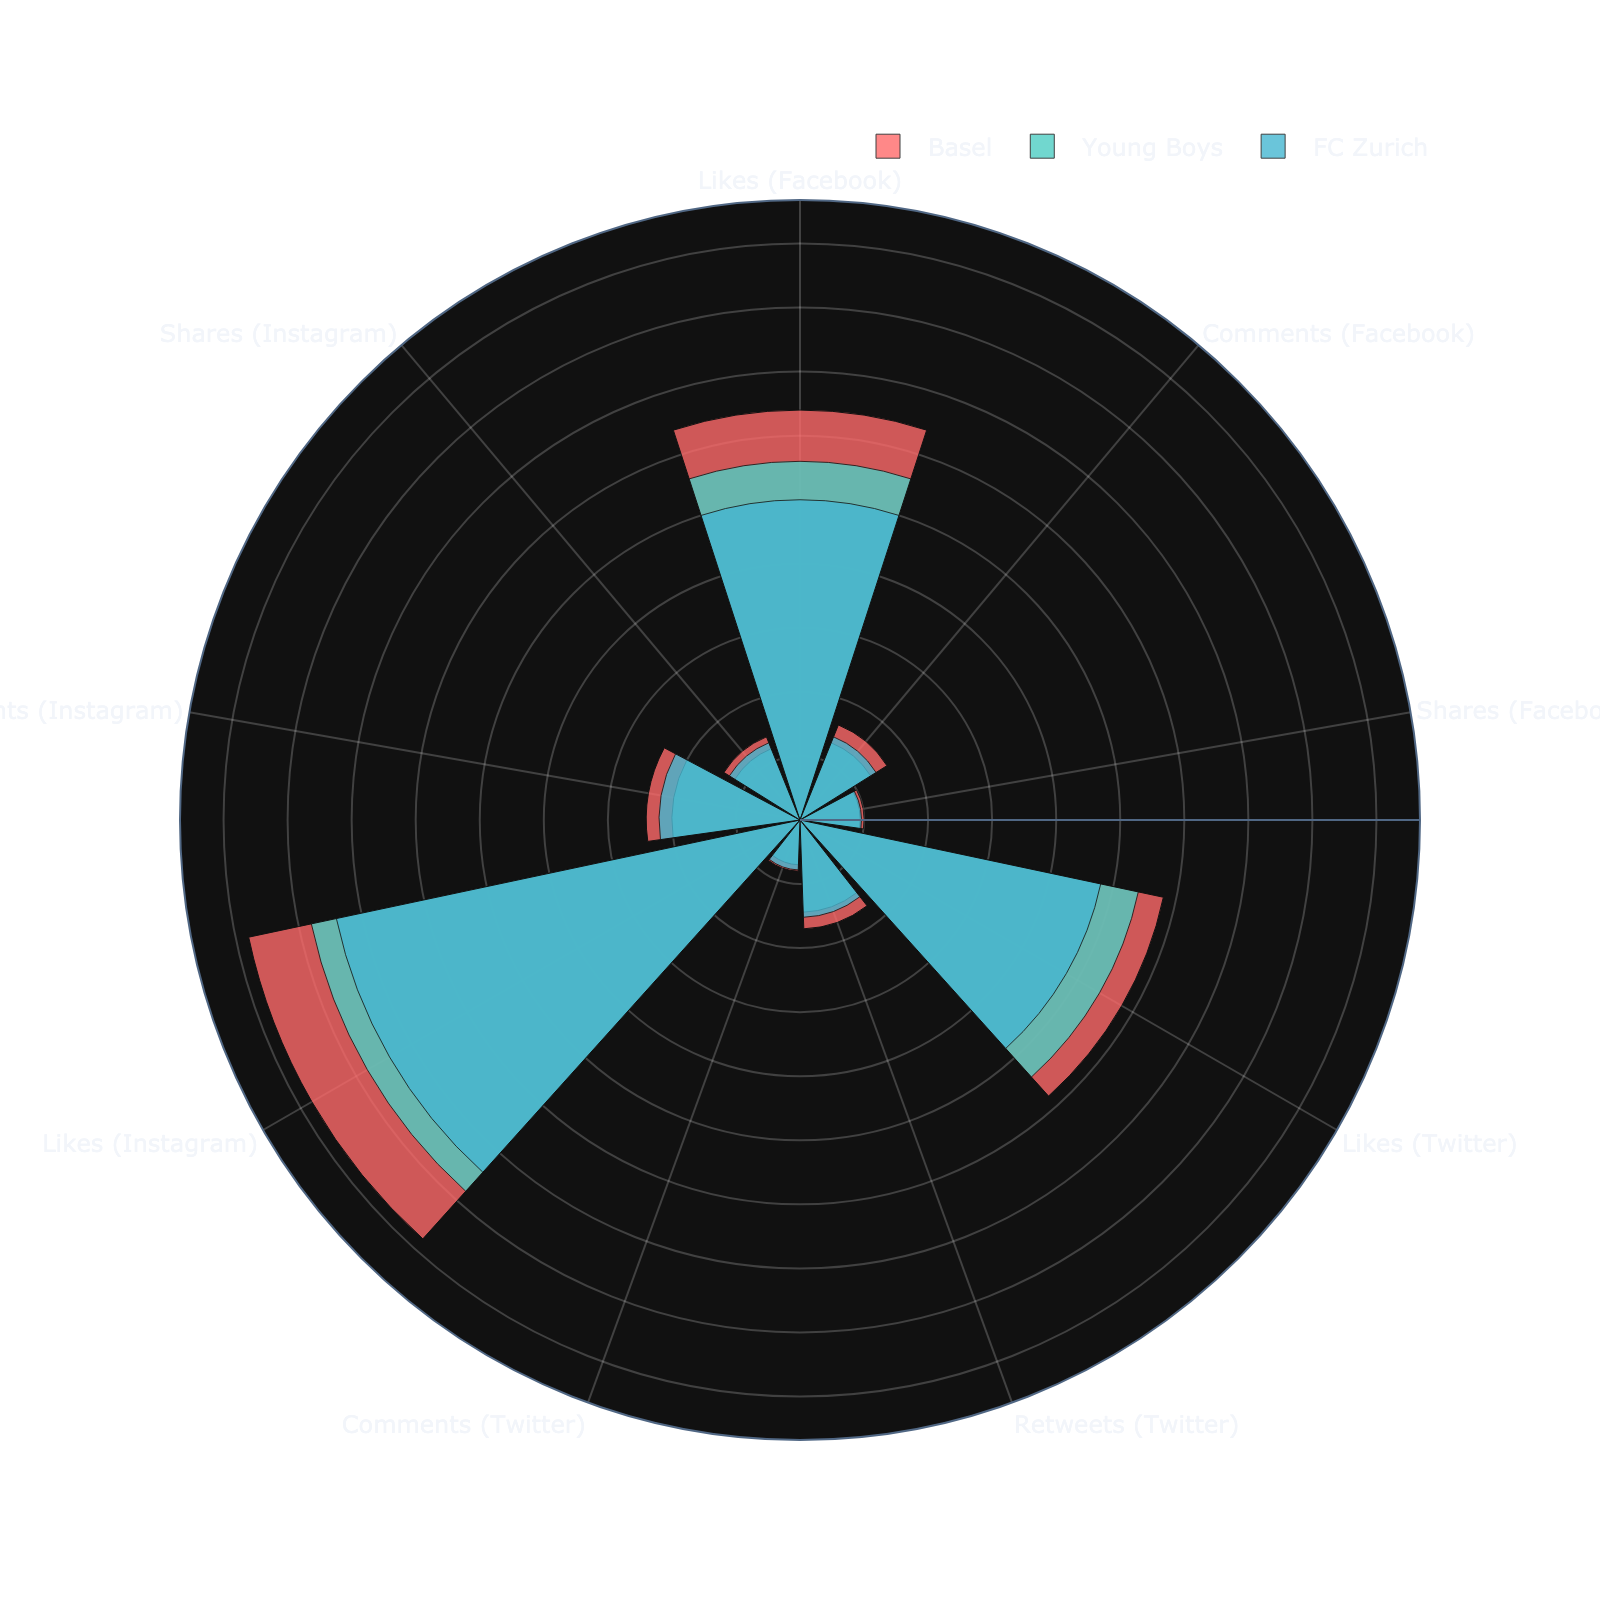What is the total number of Likes for Basel on Instagram? Add the Likes for Basel on Instagram, which is 44000.
Answer: 44000 Which platform has the highest engagement metric for FC Zurich? By looking at the data for FC Zurich, Instagram has the highest number of Likes (37000), Comments (11000), and Shares (6500), all higher than the same metrics on Facebook and Twitter.
Answer: Instagram How many more Comments does Basel have on Instagram compared to Twitter? Basel's Comments on Instagram are 12000, and on Twitter are 4000. The difference is 12000 - 4000 = 8000.
Answer: 8000 Among the three teams, which one has the highest number of Shares on Facebook? For each team on Facebook: Basel (5000), Young Boys (4700), FC Zurich (4800). Basel has the highest number.
Answer: Basel What is the average number of Likes across all platforms for Young Boys? Add Likes for Young Boys across all platforms: 28000 (Facebook) + 27000 (Twitter) + 39000 (Instagram) = 94000. Then, divide by 3 platforms: 94000 / 3 ≈ 31333.
Answer: 31333 Does FC Zurich have more Retweets on Twitter or more Comments on Facebook? FC Zurich has 7600 Retweets on Twitter and 7000 Comments on Facebook. 7600 is greater than 7000.
Answer: Retweets on Twitter Which engagement metric is the lowest for Basel on any platform? Checking Basel’s values: Likes (32000, 29000, 44000), Comments (8000, 4000, 12000), Shares (5000, 8500, 7000), the lowest is Comments on Twitter (4000).
Answer: Comments on Twitter Compare the number of Shares on Instagram for Basel and Young Boys. Who has more? Basel has 7000 Shares on Instagram and Young Boys has 6000 Shares on Instagram. Basel has more.
Answer: Basel Which club has the highest engagement in Likes across all platforms? Summing Likes for each club: Basel (32000+29000+44000=105000), Young Boys (28000+27000+39000=94000), FC Zurich (25000+24000+37000=86000). Basel has the highest total.
Answer: Basel 